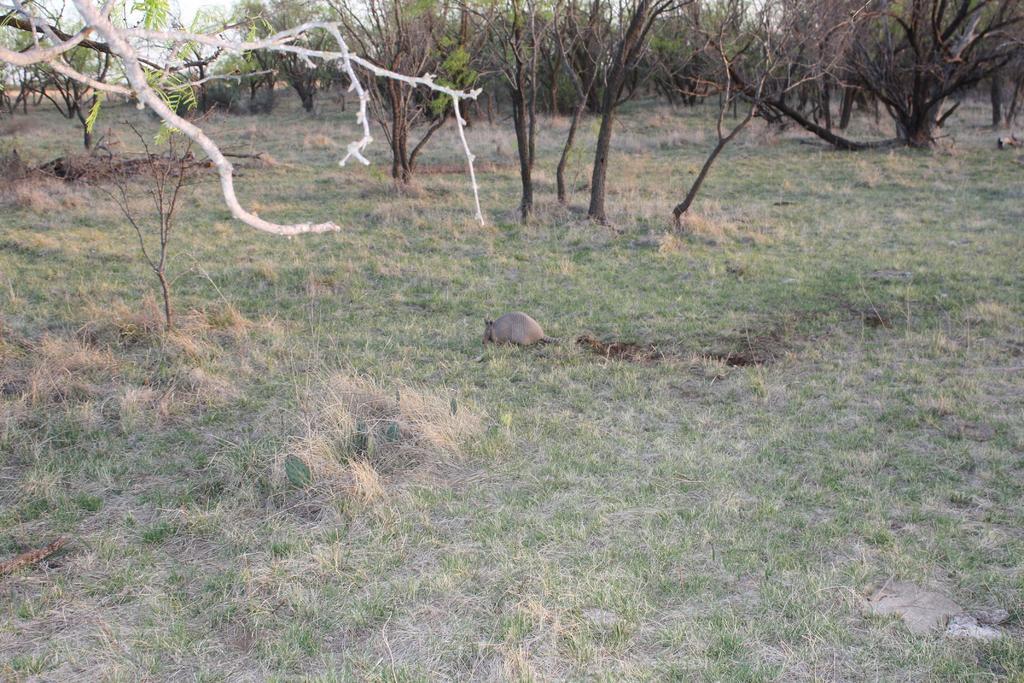Can you describe this image briefly? In this image we can see an animal on the ground. And we can see the dried grass and trees. 